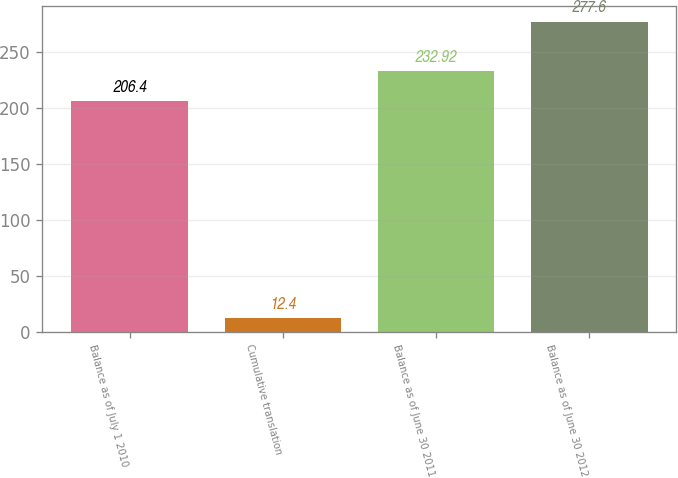<chart> <loc_0><loc_0><loc_500><loc_500><bar_chart><fcel>Balance as of July 1 2010<fcel>Cumulative translation<fcel>Balance as of June 30 2011<fcel>Balance as of June 30 2012<nl><fcel>206.4<fcel>12.4<fcel>232.92<fcel>277.6<nl></chart> 